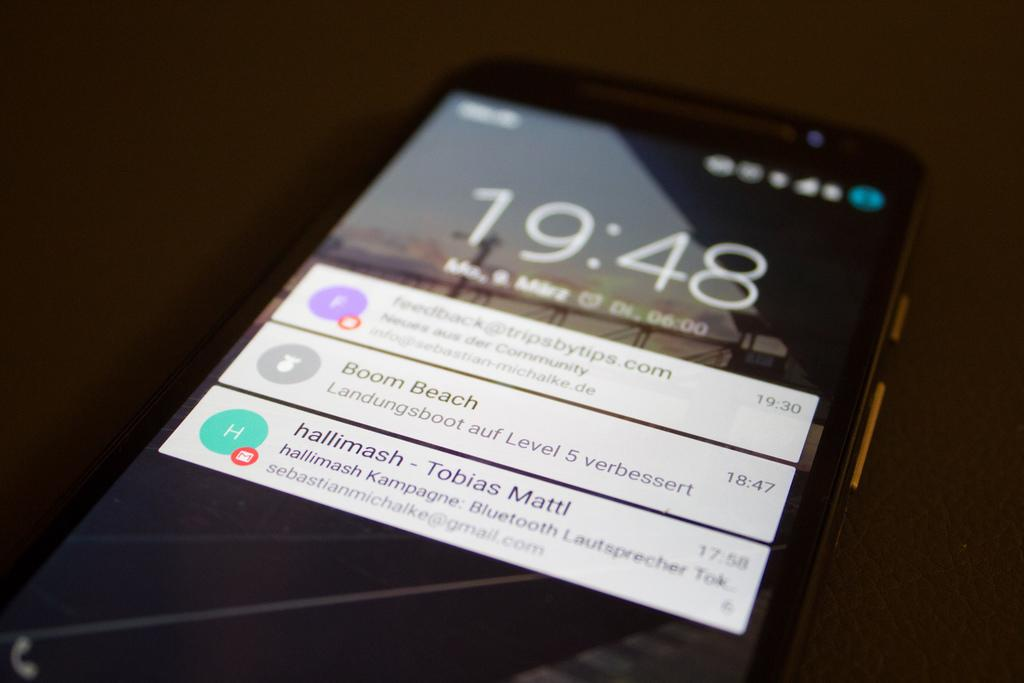What can be seen in the image? There is a mobile in the image. What is visible on the mobile screen? The mobile screen is visible, and there are notifications, the time, and other symbols on it. Can you describe the background of the image? The background of the image is blurred. What type of soup is being served in the image? There is no soup present in the image; it features a mobile with a visible screen. Can you see a pig in the image? There is no pig present in the image. 